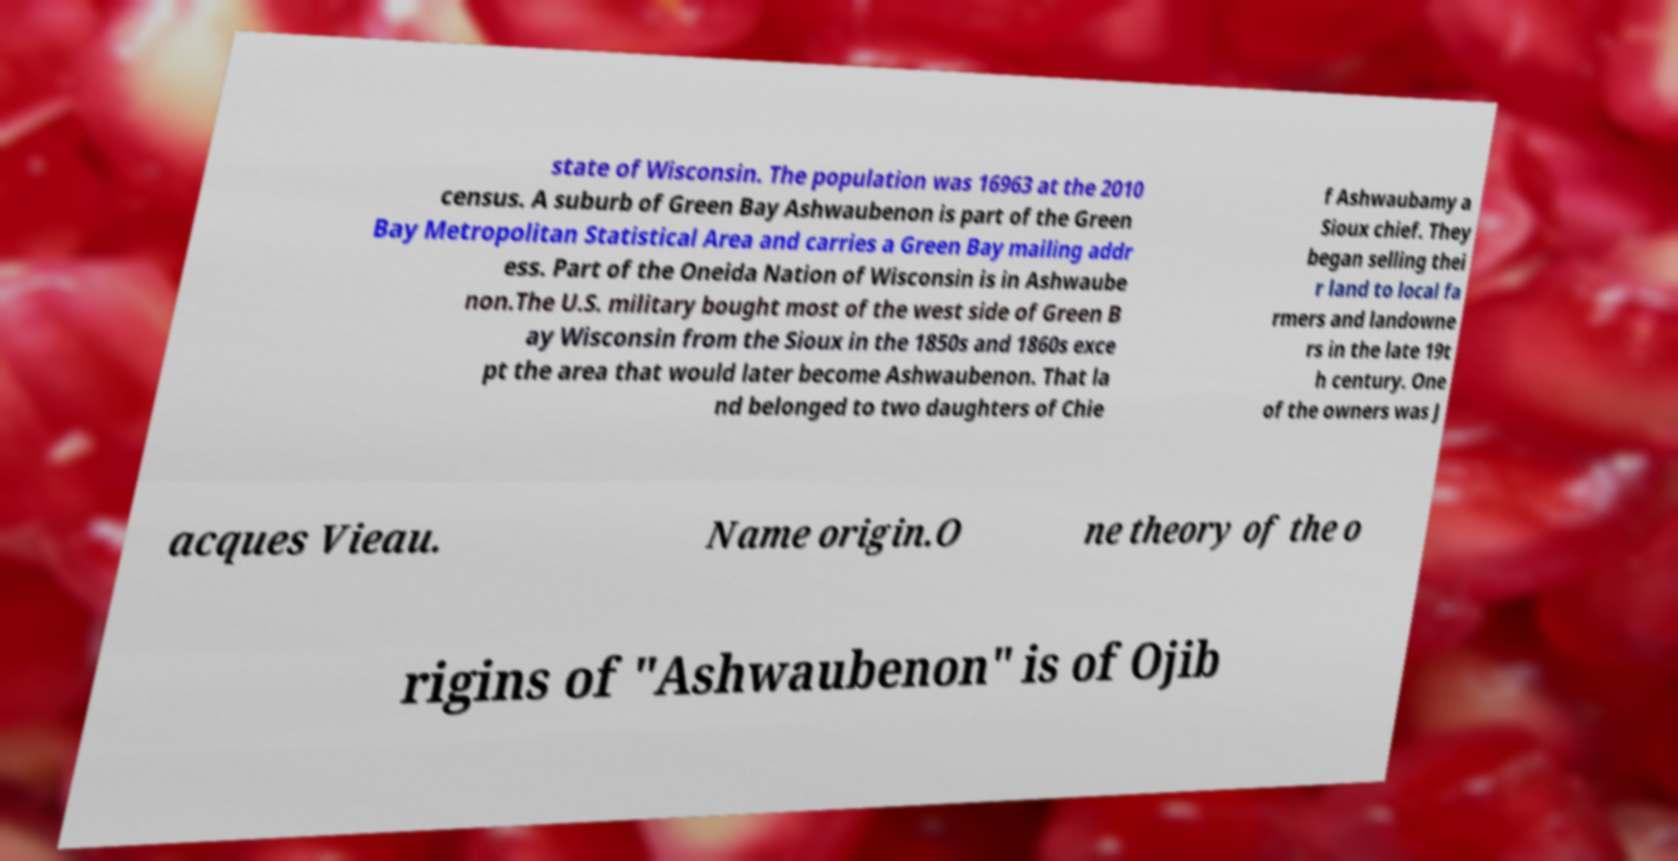Can you accurately transcribe the text from the provided image for me? state of Wisconsin. The population was 16963 at the 2010 census. A suburb of Green Bay Ashwaubenon is part of the Green Bay Metropolitan Statistical Area and carries a Green Bay mailing addr ess. Part of the Oneida Nation of Wisconsin is in Ashwaube non.The U.S. military bought most of the west side of Green B ay Wisconsin from the Sioux in the 1850s and 1860s exce pt the area that would later become Ashwaubenon. That la nd belonged to two daughters of Chie f Ashwaubamy a Sioux chief. They began selling thei r land to local fa rmers and landowne rs in the late 19t h century. One of the owners was J acques Vieau. Name origin.O ne theory of the o rigins of "Ashwaubenon" is of Ojib 